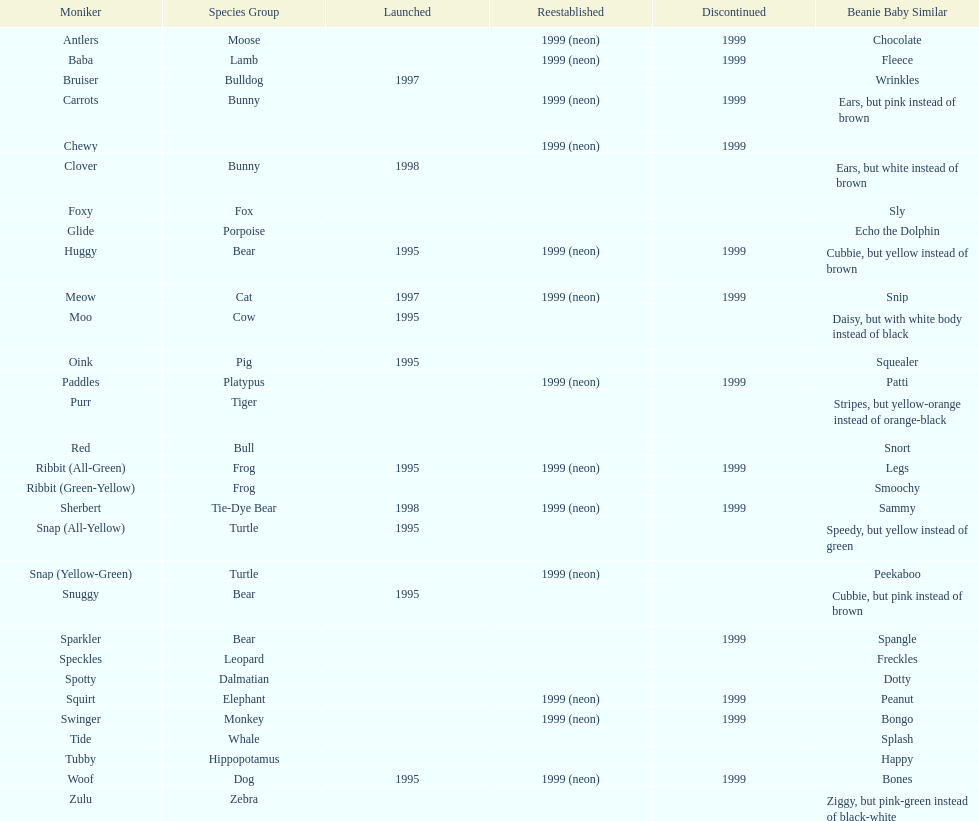How long was woof the dog sold before it was retired? 4 years. 